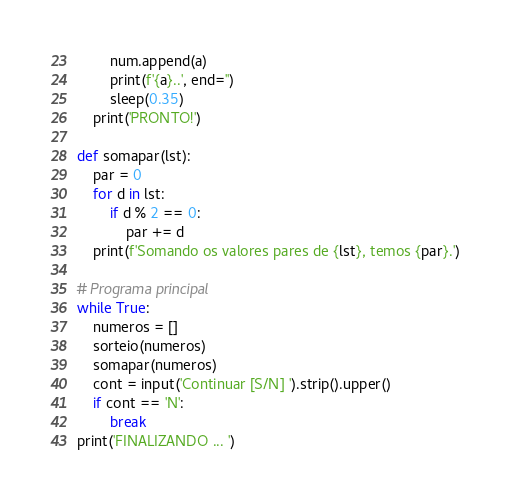<code> <loc_0><loc_0><loc_500><loc_500><_Python_>        num.append(a)
        print(f'{a}..', end='')
        sleep(0.35)
    print('PRONTO!')

def somapar(lst):
    par = 0
    for d in lst:
        if d % 2 == 0:
            par += d
    print(f'Somando os valores pares de {lst}, temos {par}.')

# Programa principal
while True:
    numeros = []
    sorteio(numeros)
    somapar(numeros)
    cont = input('Continuar [S/N] ').strip().upper()
    if cont == 'N':
        break
print('FINALIZANDO ... ')</code> 